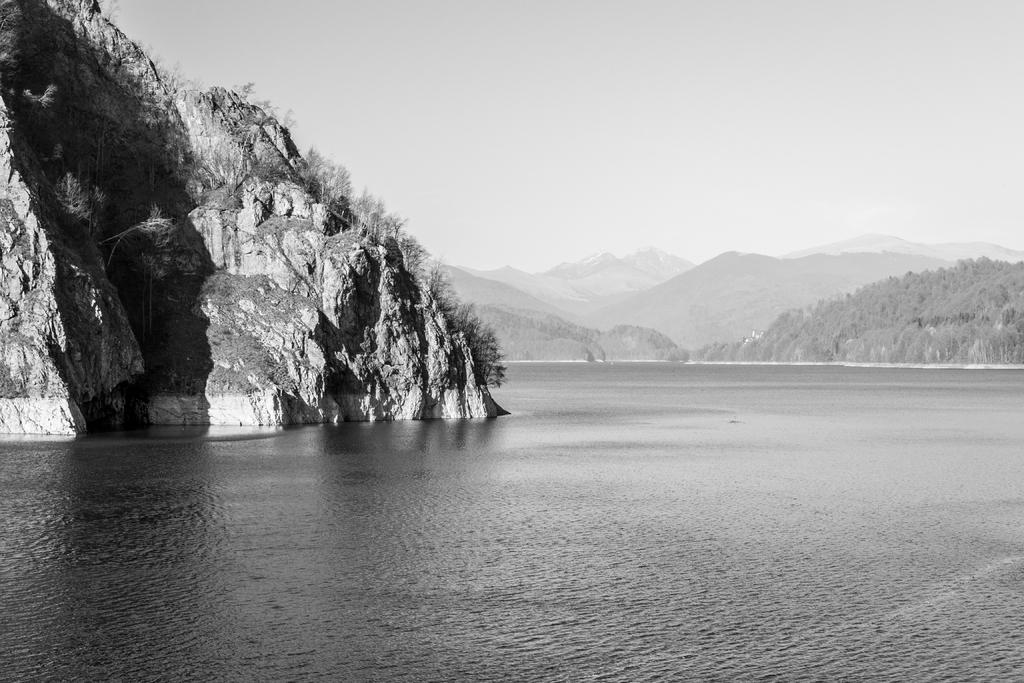What type of picture is in the image? The image contains a black and white picture. What natural element can be seen in the picture? There is water visible in the picture. What geographical feature is present in the picture? There are mountains in the picture. What type of vegetation is on the mountains? Trees are present on the mountains. What is visible in the background of the picture? The sky is visible in the background of the picture. How many bikes are parked on the mountains in the image? There are no bikes present in the image; it features a black and white picture of mountains, water, and trees. 